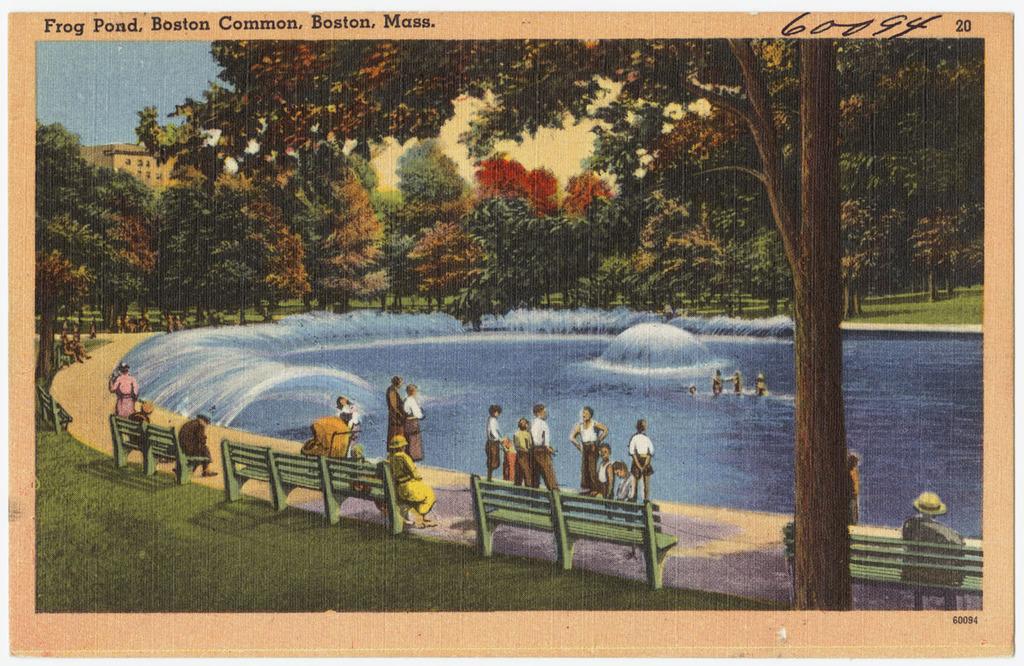What city and state is the pond located in?
Keep it short and to the point. Boston, mass. 